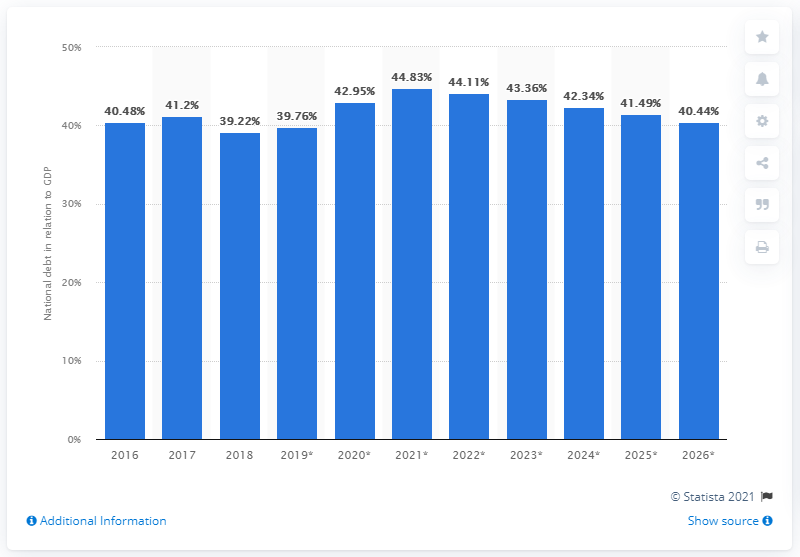List a handful of essential elements in this visual. In 2018, the national debt of Switzerland made up approximately 39.22% of the country's Gross Domestic Product (GDP). 